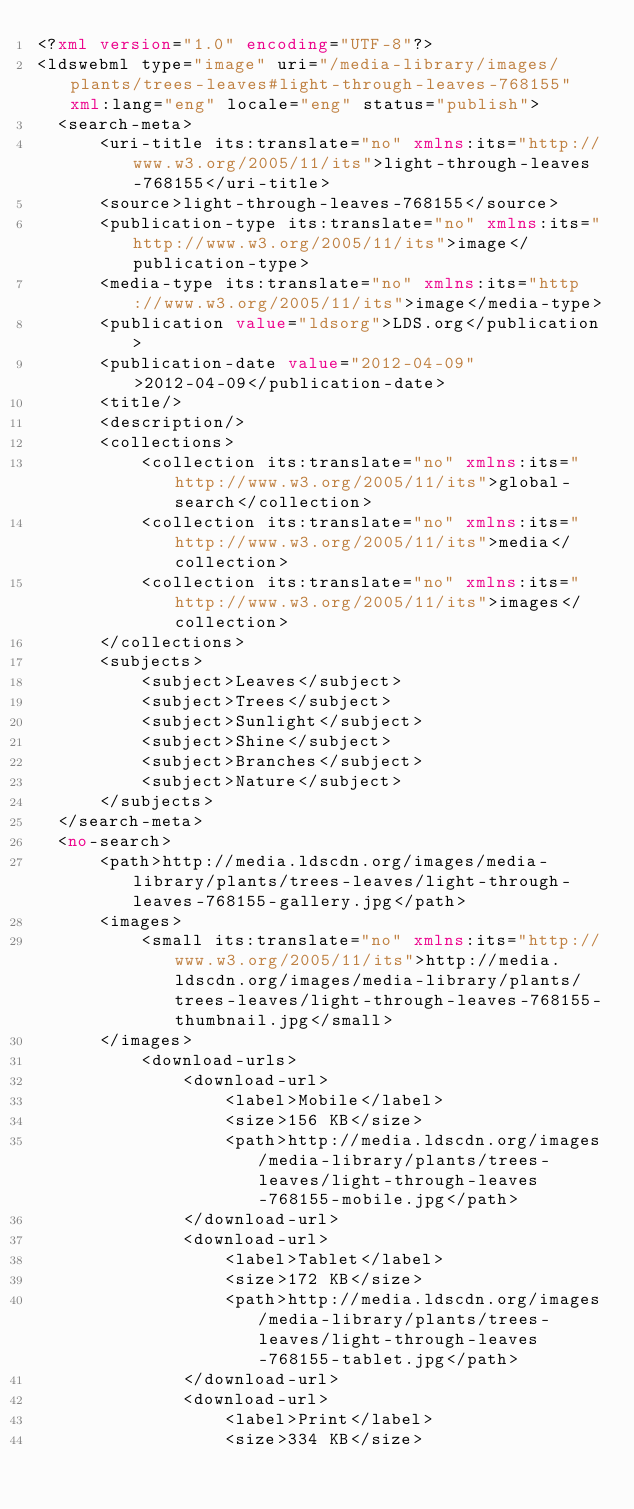<code> <loc_0><loc_0><loc_500><loc_500><_XML_><?xml version="1.0" encoding="UTF-8"?>
<ldswebml type="image" uri="/media-library/images/plants/trees-leaves#light-through-leaves-768155" xml:lang="eng" locale="eng" status="publish">
  <search-meta>
      <uri-title its:translate="no" xmlns:its="http://www.w3.org/2005/11/its">light-through-leaves-768155</uri-title>
      <source>light-through-leaves-768155</source>
      <publication-type its:translate="no" xmlns:its="http://www.w3.org/2005/11/its">image</publication-type>
      <media-type its:translate="no" xmlns:its="http://www.w3.org/2005/11/its">image</media-type>
      <publication value="ldsorg">LDS.org</publication>
      <publication-date value="2012-04-09">2012-04-09</publication-date>
      <title/>
      <description/>
      <collections>
          <collection its:translate="no" xmlns:its="http://www.w3.org/2005/11/its">global-search</collection>
          <collection its:translate="no" xmlns:its="http://www.w3.org/2005/11/its">media</collection>
          <collection its:translate="no" xmlns:its="http://www.w3.org/2005/11/its">images</collection>
      </collections>
      <subjects>
          <subject>Leaves</subject>
          <subject>Trees</subject>
          <subject>Sunlight</subject>
          <subject>Shine</subject>
          <subject>Branches</subject>
          <subject>Nature</subject>
      </subjects>
  </search-meta>
  <no-search>
      <path>http://media.ldscdn.org/images/media-library/plants/trees-leaves/light-through-leaves-768155-gallery.jpg</path>
      <images>
          <small its:translate="no" xmlns:its="http://www.w3.org/2005/11/its">http://media.ldscdn.org/images/media-library/plants/trees-leaves/light-through-leaves-768155-thumbnail.jpg</small>
      </images>
          <download-urls>
              <download-url>
                  <label>Mobile</label>
                  <size>156 KB</size>
                  <path>http://media.ldscdn.org/images/media-library/plants/trees-leaves/light-through-leaves-768155-mobile.jpg</path>
              </download-url>
              <download-url>
                  <label>Tablet</label>
                  <size>172 KB</size>
                  <path>http://media.ldscdn.org/images/media-library/plants/trees-leaves/light-through-leaves-768155-tablet.jpg</path>
              </download-url>
              <download-url>
                  <label>Print</label>
                  <size>334 KB</size></code> 